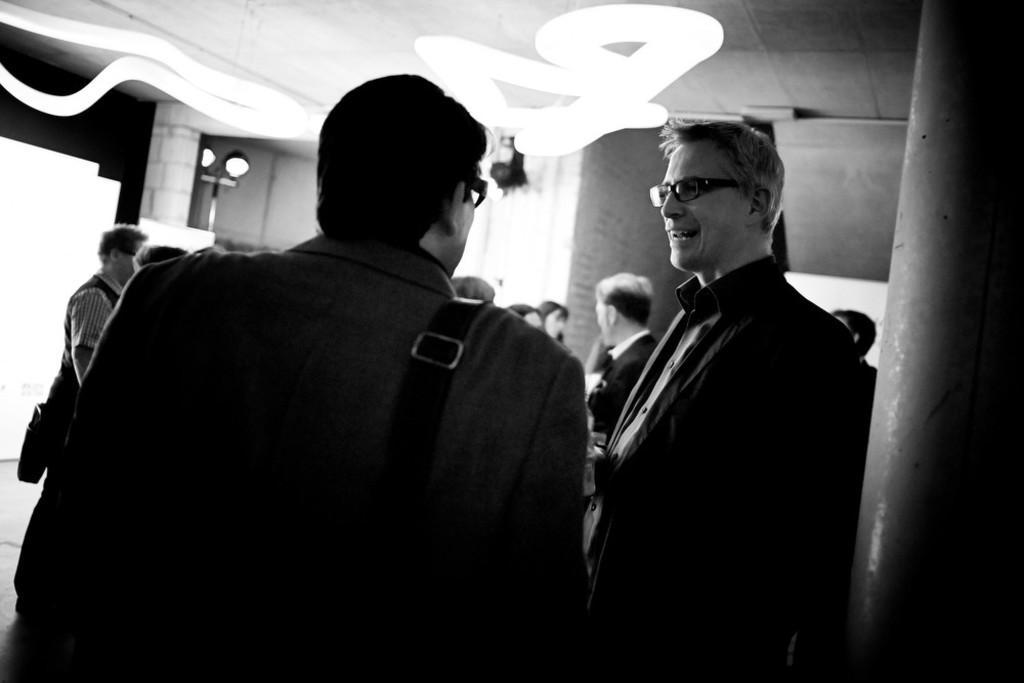Describe this image in one or two sentences. In the picture we can see two men are standing with blazers and smiling and behind them, we can see some people are standing and talking to each other and in the background, we can see a wall with lights and to the ceiling also we can see a designed light. 